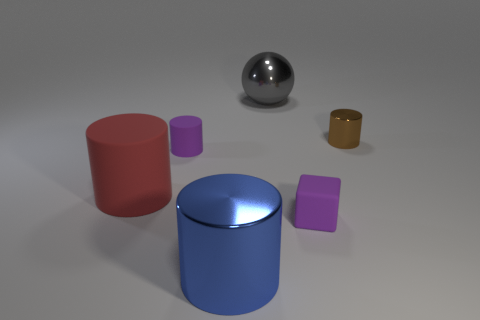How many blocks are the same size as the purple cylinder?
Ensure brevity in your answer.  1. What color is the ball?
Provide a short and direct response. Gray. Is the color of the large metallic cylinder the same as the large object to the left of the purple rubber cylinder?
Ensure brevity in your answer.  No. There is a purple cube that is made of the same material as the red object; what size is it?
Provide a succinct answer. Small. Is there another big metallic cylinder of the same color as the large metallic cylinder?
Provide a succinct answer. No. What number of things are metallic things behind the big blue thing or big green matte spheres?
Provide a succinct answer. 2. Is the small brown cylinder made of the same material as the big cylinder on the right side of the large matte thing?
Your answer should be compact. Yes. What size is the cylinder that is the same color as the matte cube?
Offer a terse response. Small. Are there any brown cylinders made of the same material as the large red thing?
Make the answer very short. No. How many objects are either rubber objects that are to the right of the big gray ball or metallic cylinders that are on the left side of the gray sphere?
Offer a very short reply. 2. 